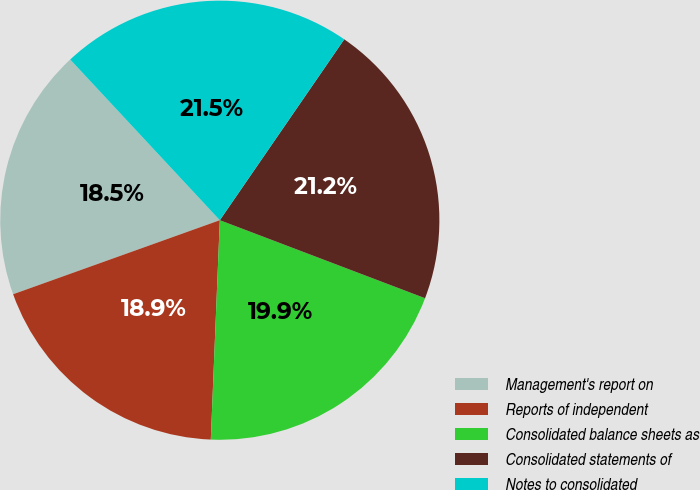<chart> <loc_0><loc_0><loc_500><loc_500><pie_chart><fcel>Management's report on<fcel>Reports of independent<fcel>Consolidated balance sheets as<fcel>Consolidated statements of<fcel>Notes to consolidated<nl><fcel>18.54%<fcel>18.87%<fcel>19.87%<fcel>21.19%<fcel>21.52%<nl></chart> 